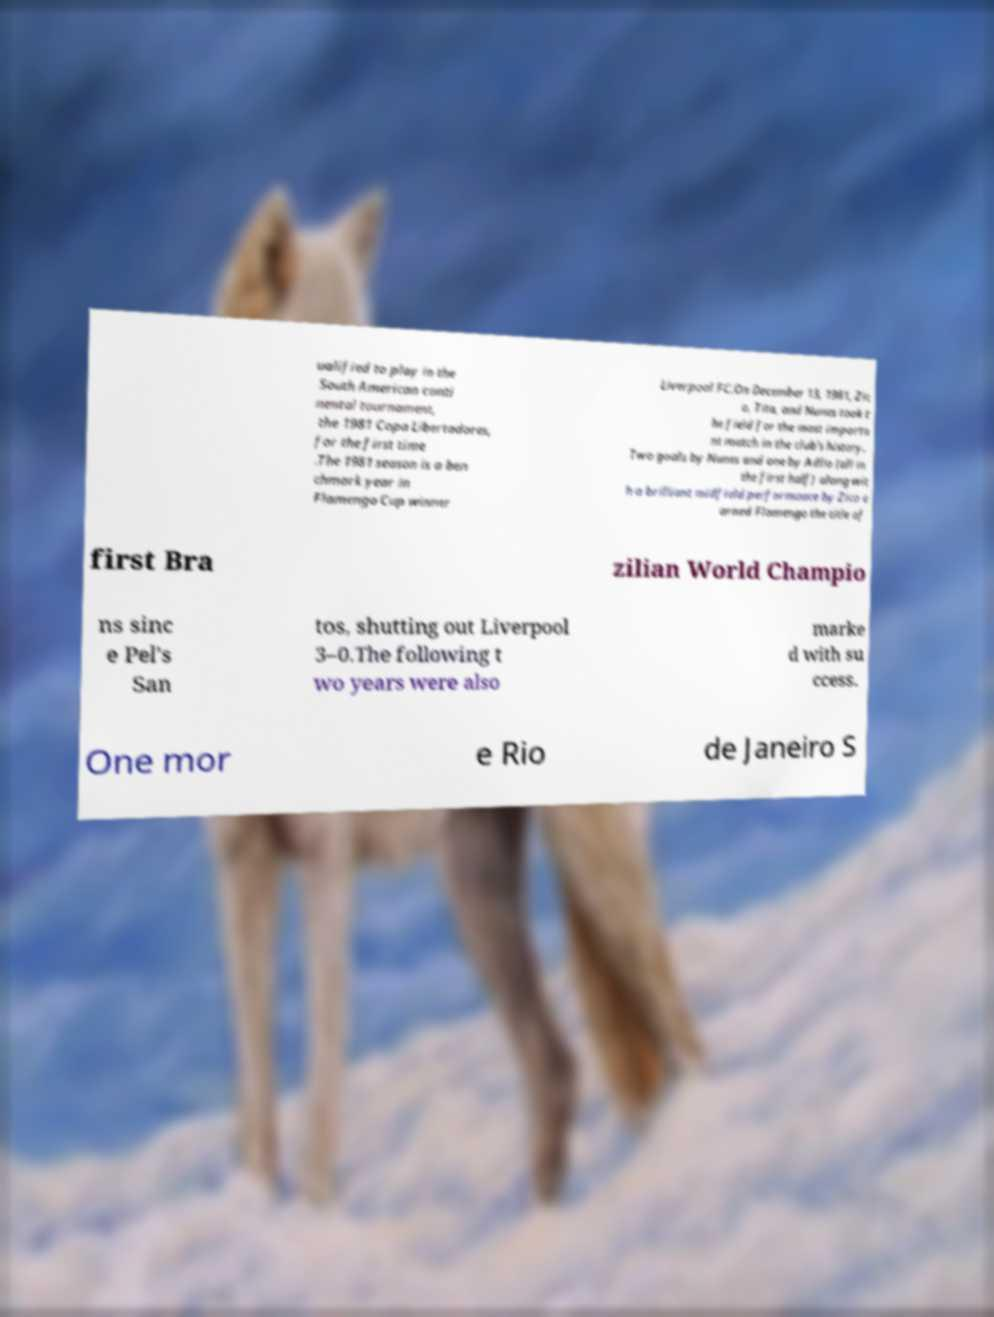Could you extract and type out the text from this image? ualified to play in the South American conti nental tournament, the 1981 Copa Libertadores, for the first time .The 1981 season is a ben chmark year in Flamengo Cup winner Liverpool FC.On December 13, 1981, Zic o, Tita, and Nunes took t he field for the most importa nt match in the club's history. Two goals by Nunes and one by Adlio (all in the first half) along wit h a brilliant midfield performance by Zico e arned Flamengo the title of first Bra zilian World Champio ns sinc e Pel's San tos, shutting out Liverpool 3–0.The following t wo years were also marke d with su ccess. One mor e Rio de Janeiro S 